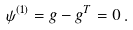<formula> <loc_0><loc_0><loc_500><loc_500>\psi ^ { ( 1 ) } = g - g ^ { T } = 0 \, .</formula> 